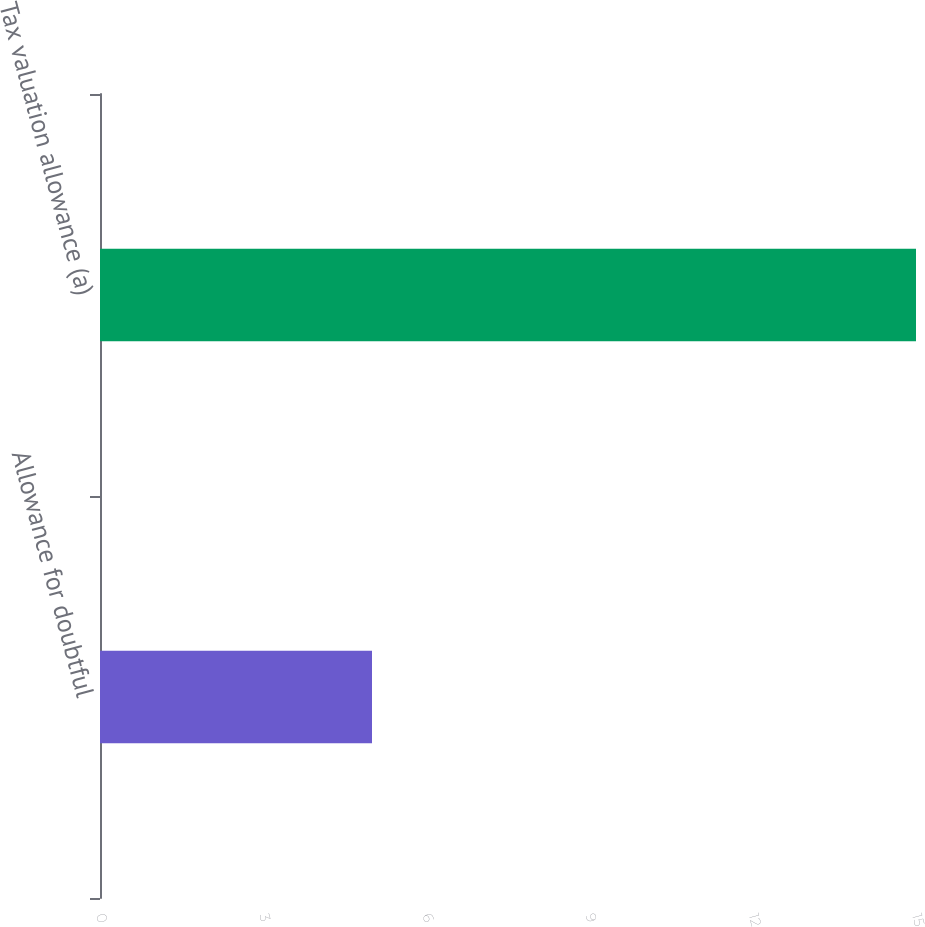Convert chart. <chart><loc_0><loc_0><loc_500><loc_500><bar_chart><fcel>Allowance for doubtful<fcel>Tax valuation allowance (a)<nl><fcel>5<fcel>15<nl></chart> 